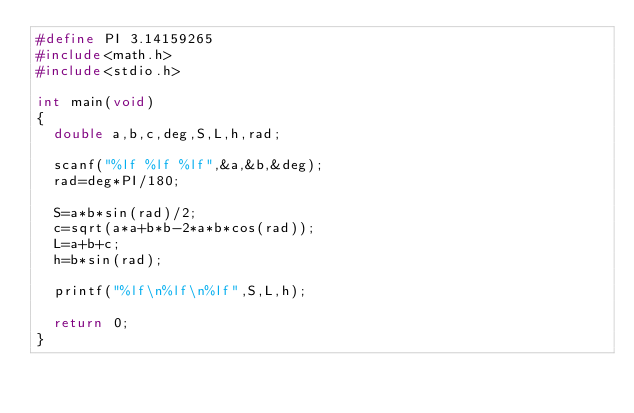Convert code to text. <code><loc_0><loc_0><loc_500><loc_500><_C_>#define PI 3.14159265
#include<math.h>
#include<stdio.h>

int main(void)
{
	double a,b,c,deg,S,L,h,rad;

	scanf("%lf %lf %lf",&a,&b,&deg);
	rad=deg*PI/180;

	S=a*b*sin(rad)/2;
	c=sqrt(a*a+b*b-2*a*b*cos(rad));
	L=a+b+c;
	h=b*sin(rad);
	
	printf("%lf\n%lf\n%lf",S,L,h);

	return 0;
}
</code> 